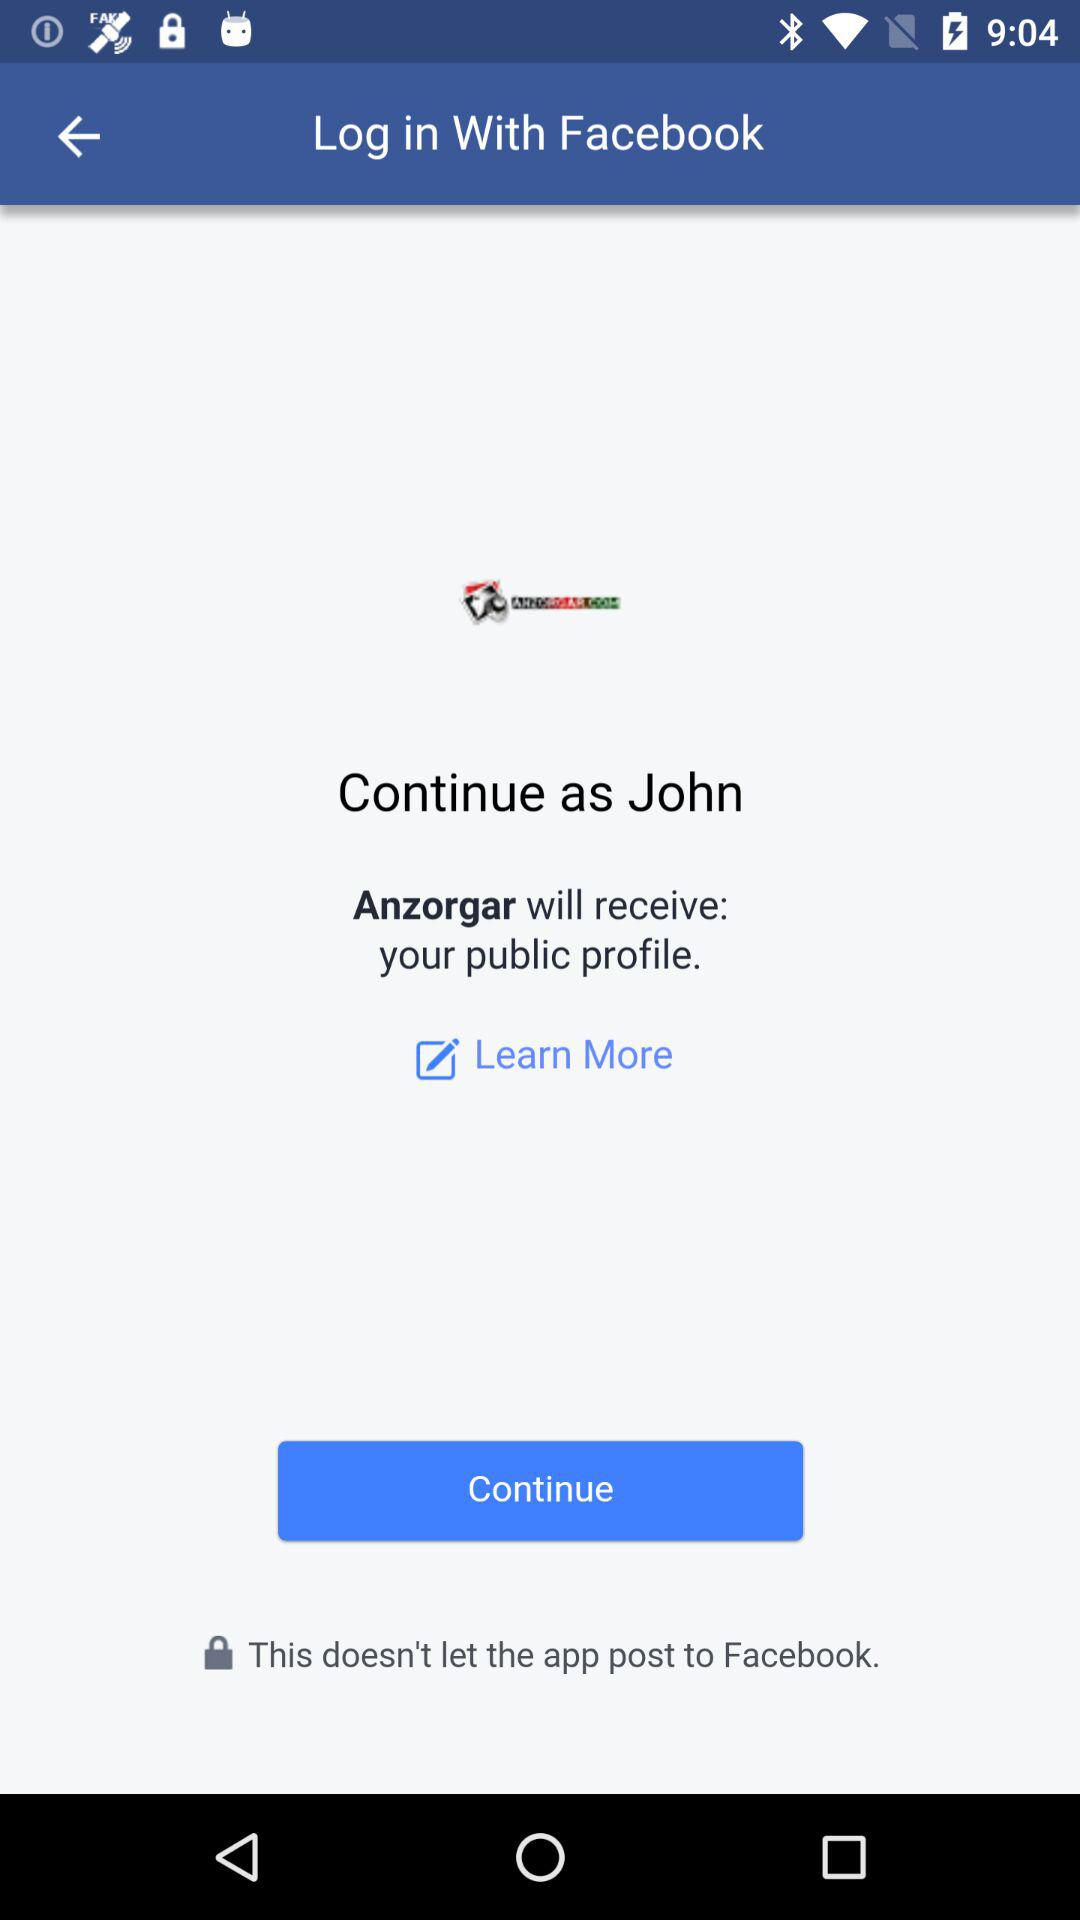What is the name of the application? The application names are "Facebook" and "Anzorgar". 